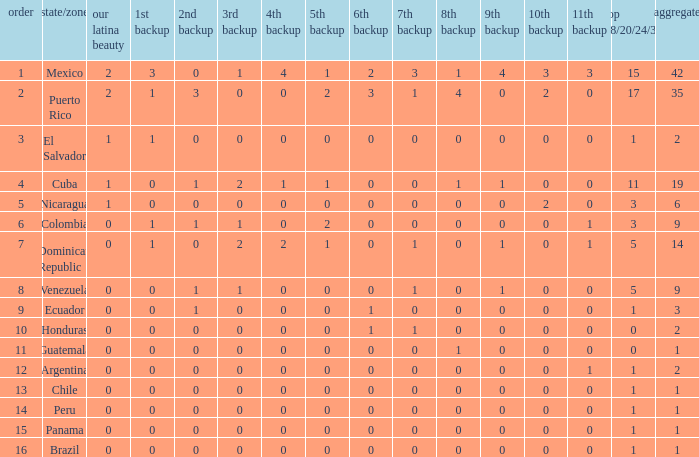What is the average total of the country with a 4th runner-up of 0 and a Nuestra Bellaza Latina less than 0? None. 